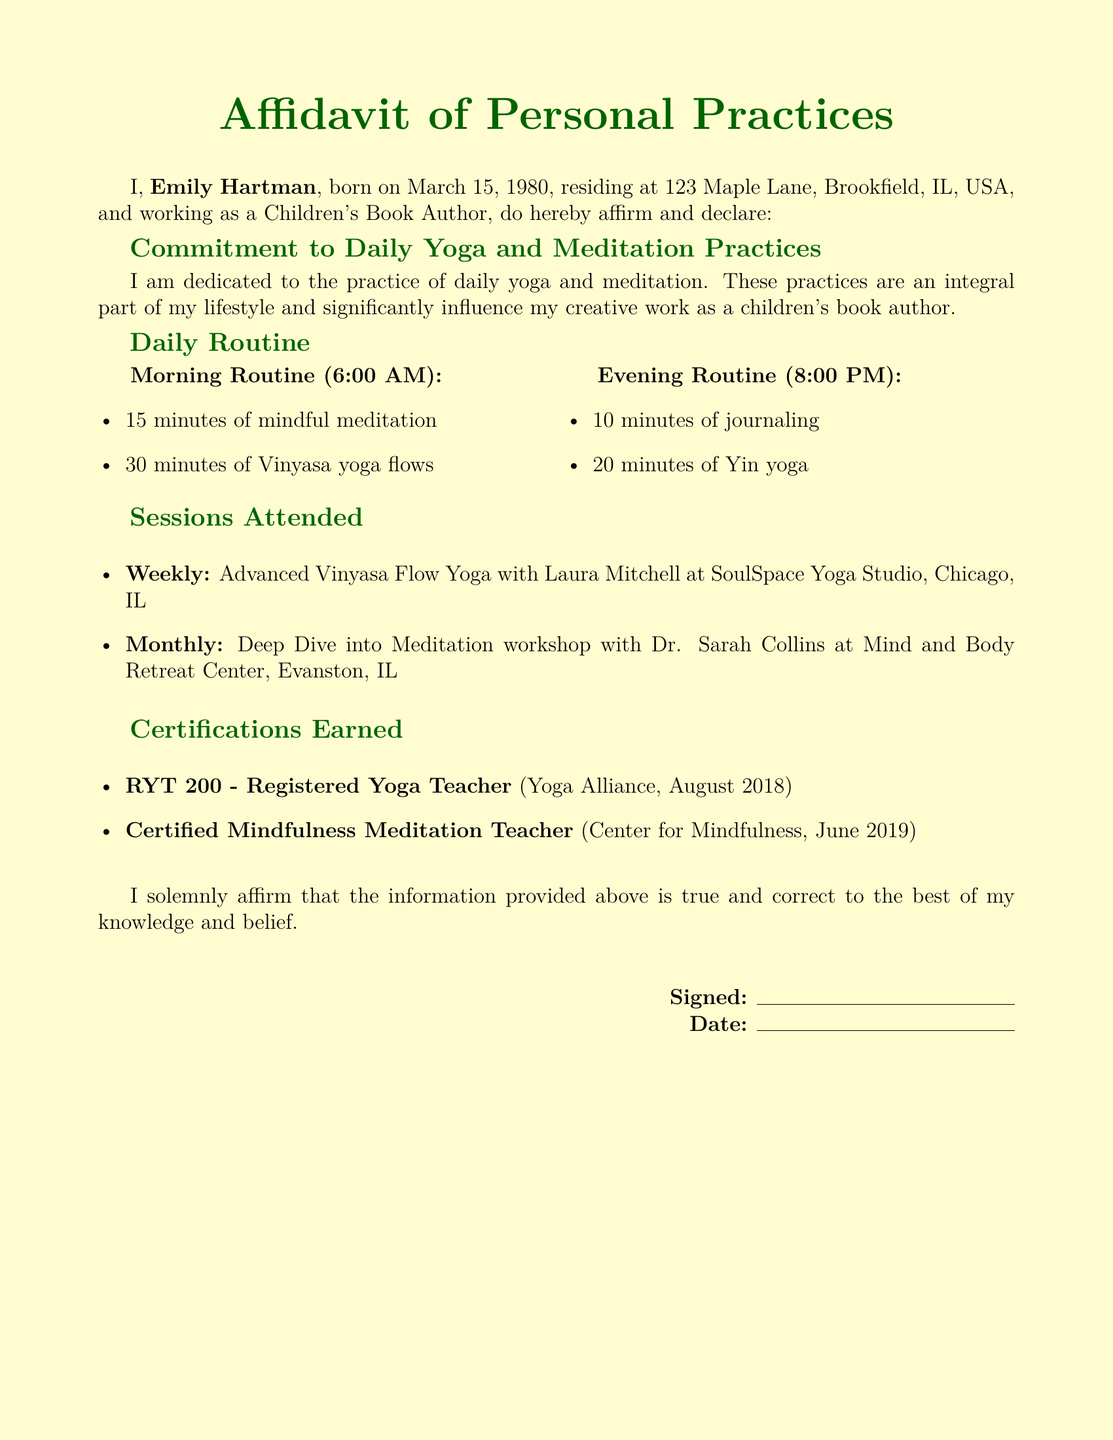What is the author's name? The author's name is stated at the beginning of the document as Emily Hartman.
Answer: Emily Hartman What is the author's date of birth? The date of birth is mentioned in the affidavit as March 15, 1980.
Answer: March 15, 1980 What time does the morning yoga session start? The document specifies that the morning routine starts at 6:00 AM.
Answer: 6:00 AM How long is the evening journaling session? The length of the evening journaling session is described as 10 minutes.
Answer: 10 minutes What is the certification earned by the author in June 2019? The certification earned is stated as Certified Mindfulness Meditation Teacher.
Answer: Certified Mindfulness Meditation Teacher What type of yoga does the author practice in the evening? The evening practice is specified as Yin yoga.
Answer: Yin yoga How many minutes are dedicated to Vinyasa yoga flows in the morning? The document states that 30 minutes are dedicated to Vinyasa yoga flows.
Answer: 30 minutes What is the name of the studio where the weekly session is attended? The weekly session is attended at SoulSpace Yoga Studio.
Answer: SoulSpace Yoga Studio What workshop does the author attend monthly? The monthly session is a Deep Dive into Meditation workshop.
Answer: Deep Dive into Meditation workshop 